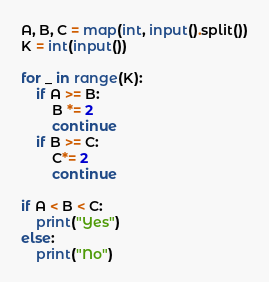<code> <loc_0><loc_0><loc_500><loc_500><_Python_>A, B, C = map(int, input().split())
K = int(input())

for _ in range(K):
    if A >= B:
        B *= 2
        continue
    if B >= C:
        C*= 2
        continue

if A < B < C:
    print("Yes")
else:
    print("No")</code> 